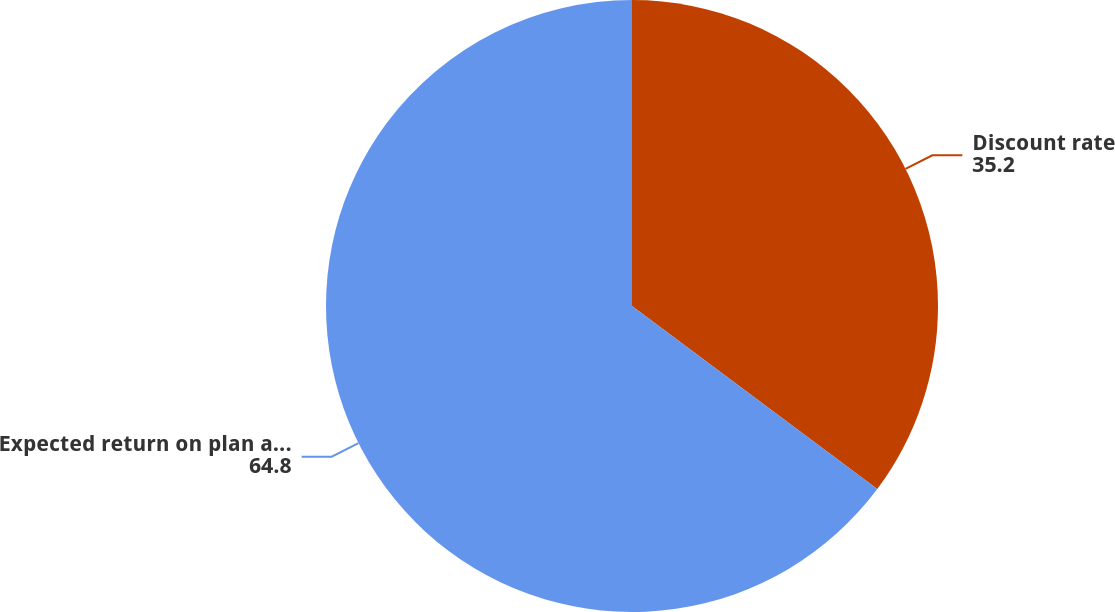Convert chart. <chart><loc_0><loc_0><loc_500><loc_500><pie_chart><fcel>Discount rate<fcel>Expected return on plan assets<nl><fcel>35.2%<fcel>64.8%<nl></chart> 